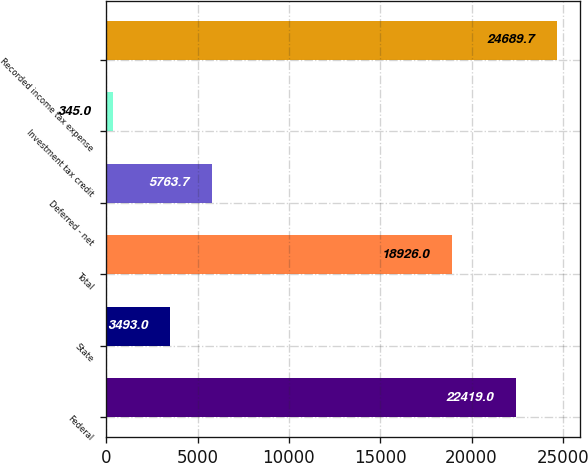Convert chart to OTSL. <chart><loc_0><loc_0><loc_500><loc_500><bar_chart><fcel>Federal<fcel>State<fcel>Total<fcel>Deferred - net<fcel>Investment tax credit<fcel>Recorded income tax expense<nl><fcel>22419<fcel>3493<fcel>18926<fcel>5763.7<fcel>345<fcel>24689.7<nl></chart> 